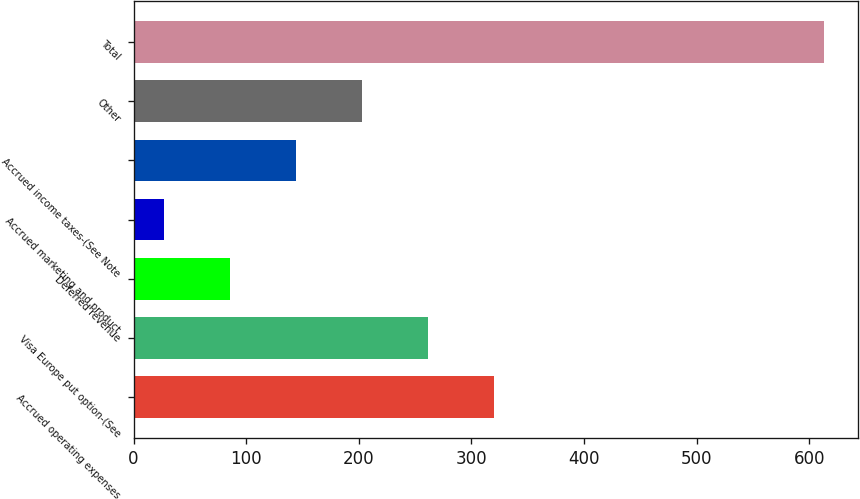<chart> <loc_0><loc_0><loc_500><loc_500><bar_chart><fcel>Accrued operating expenses<fcel>Visa Europe put option-(See<fcel>Deferred revenue<fcel>Accrued marketing and product<fcel>Accrued income taxes-(See Note<fcel>Other<fcel>Total<nl><fcel>320<fcel>261.4<fcel>85.6<fcel>27<fcel>144.2<fcel>202.8<fcel>613<nl></chart> 